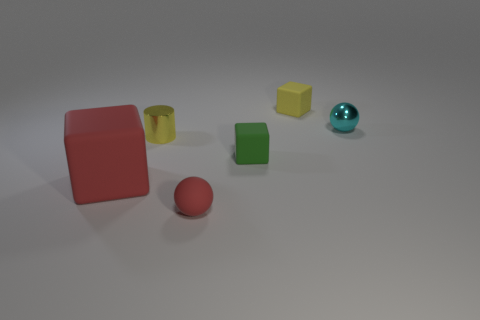Add 3 cylinders. How many objects exist? 9 Subtract all cylinders. How many objects are left? 5 Add 4 small green objects. How many small green objects exist? 5 Subtract 0 cyan cylinders. How many objects are left? 6 Subtract all large green metal objects. Subtract all yellow metallic objects. How many objects are left? 5 Add 1 small yellow blocks. How many small yellow blocks are left? 2 